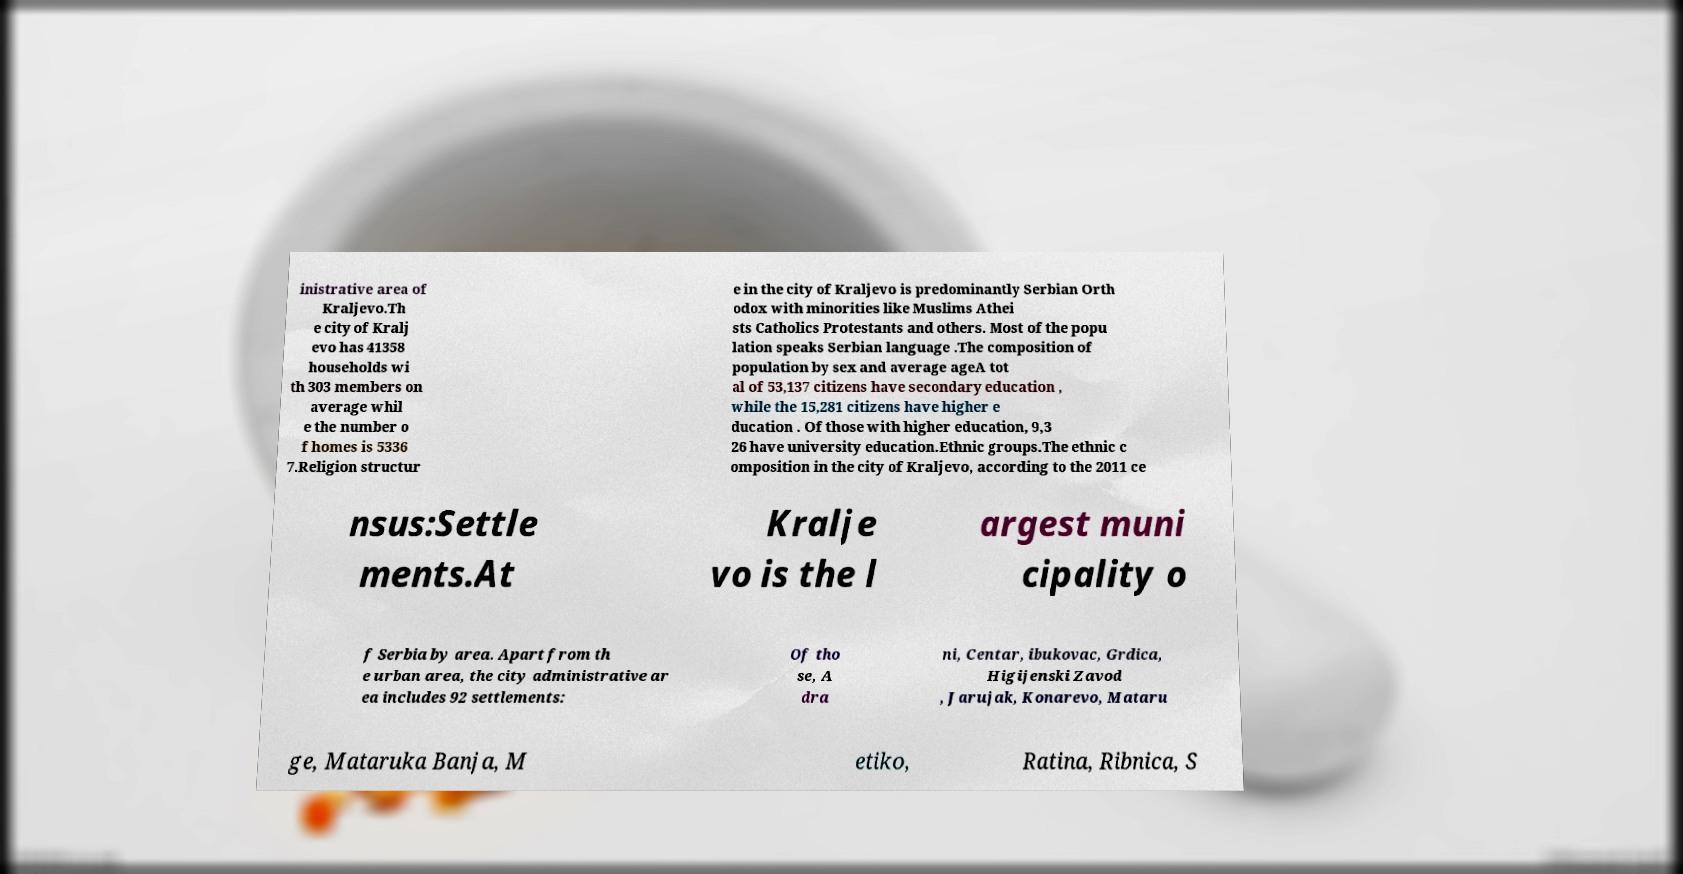Please identify and transcribe the text found in this image. inistrative area of Kraljevo.Th e city of Kralj evo has 41358 households wi th 303 members on average whil e the number o f homes is 5336 7.Religion structur e in the city of Kraljevo is predominantly Serbian Orth odox with minorities like Muslims Athei sts Catholics Protestants and others. Most of the popu lation speaks Serbian language .The composition of population by sex and average ageA tot al of 53,137 citizens have secondary education , while the 15,281 citizens have higher e ducation . Of those with higher education, 9,3 26 have university education.Ethnic groups.The ethnic c omposition in the city of Kraljevo, according to the 2011 ce nsus:Settle ments.At Kralje vo is the l argest muni cipality o f Serbia by area. Apart from th e urban area, the city administrative ar ea includes 92 settlements: Of tho se, A dra ni, Centar, ibukovac, Grdica, Higijenski Zavod , Jarujak, Konarevo, Mataru ge, Mataruka Banja, M etiko, Ratina, Ribnica, S 